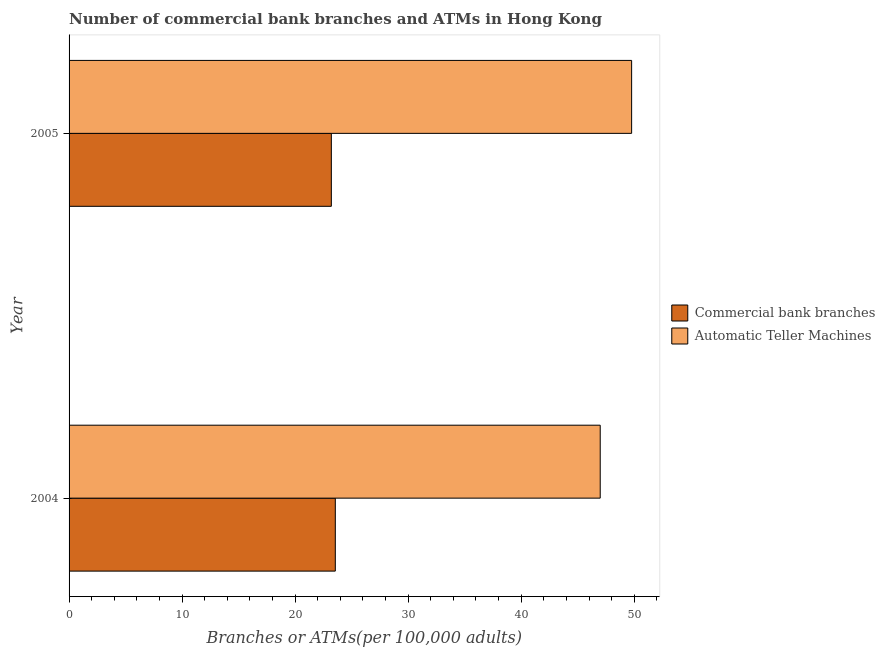What is the label of the 1st group of bars from the top?
Offer a very short reply. 2005. What is the number of atms in 2004?
Keep it short and to the point. 46.99. Across all years, what is the maximum number of atms?
Your response must be concise. 49.77. Across all years, what is the minimum number of commercal bank branches?
Your answer should be compact. 23.2. In which year was the number of commercal bank branches maximum?
Offer a very short reply. 2004. In which year was the number of commercal bank branches minimum?
Ensure brevity in your answer.  2005. What is the total number of atms in the graph?
Keep it short and to the point. 96.76. What is the difference between the number of atms in 2004 and that in 2005?
Give a very brief answer. -2.78. What is the difference between the number of commercal bank branches in 2005 and the number of atms in 2004?
Offer a very short reply. -23.79. What is the average number of commercal bank branches per year?
Give a very brief answer. 23.38. In the year 2005, what is the difference between the number of commercal bank branches and number of atms?
Keep it short and to the point. -26.57. In how many years, is the number of commercal bank branches greater than 6 ?
Offer a very short reply. 2. Is the number of commercal bank branches in 2004 less than that in 2005?
Provide a short and direct response. No. In how many years, is the number of atms greater than the average number of atms taken over all years?
Your answer should be very brief. 1. What does the 1st bar from the top in 2005 represents?
Your answer should be compact. Automatic Teller Machines. What does the 1st bar from the bottom in 2004 represents?
Give a very brief answer. Commercial bank branches. What is the difference between two consecutive major ticks on the X-axis?
Offer a very short reply. 10. Does the graph contain grids?
Your response must be concise. No. How many legend labels are there?
Provide a short and direct response. 2. How are the legend labels stacked?
Make the answer very short. Vertical. What is the title of the graph?
Offer a very short reply. Number of commercial bank branches and ATMs in Hong Kong. Does "Excluding technical cooperation" appear as one of the legend labels in the graph?
Ensure brevity in your answer.  No. What is the label or title of the X-axis?
Provide a short and direct response. Branches or ATMs(per 100,0 adults). What is the Branches or ATMs(per 100,000 adults) of Commercial bank branches in 2004?
Ensure brevity in your answer.  23.56. What is the Branches or ATMs(per 100,000 adults) in Automatic Teller Machines in 2004?
Your answer should be very brief. 46.99. What is the Branches or ATMs(per 100,000 adults) of Commercial bank branches in 2005?
Offer a terse response. 23.2. What is the Branches or ATMs(per 100,000 adults) in Automatic Teller Machines in 2005?
Your answer should be compact. 49.77. Across all years, what is the maximum Branches or ATMs(per 100,000 adults) in Commercial bank branches?
Your answer should be compact. 23.56. Across all years, what is the maximum Branches or ATMs(per 100,000 adults) in Automatic Teller Machines?
Give a very brief answer. 49.77. Across all years, what is the minimum Branches or ATMs(per 100,000 adults) in Commercial bank branches?
Provide a short and direct response. 23.2. Across all years, what is the minimum Branches or ATMs(per 100,000 adults) of Automatic Teller Machines?
Provide a succinct answer. 46.99. What is the total Branches or ATMs(per 100,000 adults) in Commercial bank branches in the graph?
Keep it short and to the point. 46.76. What is the total Branches or ATMs(per 100,000 adults) of Automatic Teller Machines in the graph?
Provide a succinct answer. 96.76. What is the difference between the Branches or ATMs(per 100,000 adults) of Commercial bank branches in 2004 and that in 2005?
Your answer should be very brief. 0.35. What is the difference between the Branches or ATMs(per 100,000 adults) in Automatic Teller Machines in 2004 and that in 2005?
Make the answer very short. -2.78. What is the difference between the Branches or ATMs(per 100,000 adults) in Commercial bank branches in 2004 and the Branches or ATMs(per 100,000 adults) in Automatic Teller Machines in 2005?
Offer a terse response. -26.22. What is the average Branches or ATMs(per 100,000 adults) of Commercial bank branches per year?
Your response must be concise. 23.38. What is the average Branches or ATMs(per 100,000 adults) of Automatic Teller Machines per year?
Make the answer very short. 48.38. In the year 2004, what is the difference between the Branches or ATMs(per 100,000 adults) of Commercial bank branches and Branches or ATMs(per 100,000 adults) of Automatic Teller Machines?
Offer a terse response. -23.44. In the year 2005, what is the difference between the Branches or ATMs(per 100,000 adults) in Commercial bank branches and Branches or ATMs(per 100,000 adults) in Automatic Teller Machines?
Offer a very short reply. -26.57. What is the ratio of the Branches or ATMs(per 100,000 adults) in Commercial bank branches in 2004 to that in 2005?
Offer a terse response. 1.02. What is the ratio of the Branches or ATMs(per 100,000 adults) in Automatic Teller Machines in 2004 to that in 2005?
Keep it short and to the point. 0.94. What is the difference between the highest and the second highest Branches or ATMs(per 100,000 adults) of Commercial bank branches?
Provide a succinct answer. 0.35. What is the difference between the highest and the second highest Branches or ATMs(per 100,000 adults) of Automatic Teller Machines?
Ensure brevity in your answer.  2.78. What is the difference between the highest and the lowest Branches or ATMs(per 100,000 adults) of Commercial bank branches?
Your response must be concise. 0.35. What is the difference between the highest and the lowest Branches or ATMs(per 100,000 adults) of Automatic Teller Machines?
Ensure brevity in your answer.  2.78. 